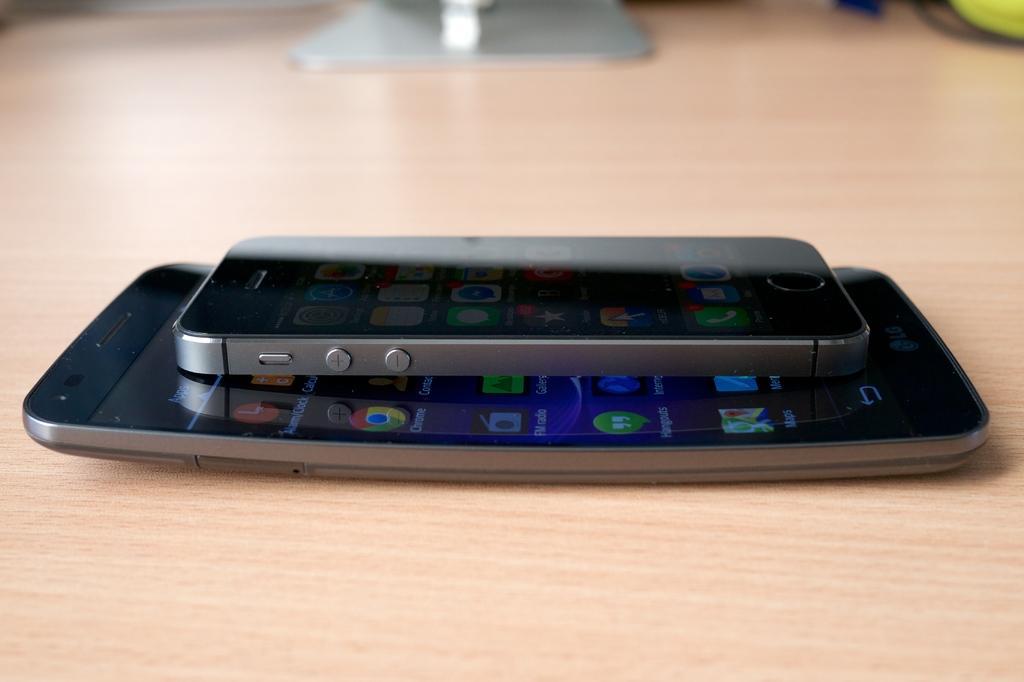Can you describe this image briefly? There are two mobile phones on a wooden plank in the image. Screen has few apps visible on it. 